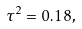<formula> <loc_0><loc_0><loc_500><loc_500>\tau ^ { 2 } = 0 . 1 8 ,</formula> 